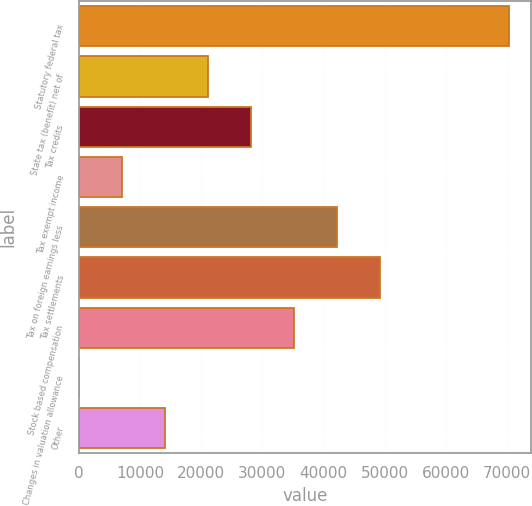Convert chart. <chart><loc_0><loc_0><loc_500><loc_500><bar_chart><fcel>Statutory federal tax<fcel>State tax (benefit) net of<fcel>Tax credits<fcel>Tax exempt income<fcel>Tax on foreign earnings less<fcel>Tax settlements<fcel>Stock based compensation<fcel>Changes in valuation allowance<fcel>Other<nl><fcel>70397<fcel>21126.1<fcel>28164.8<fcel>7048.7<fcel>42242.2<fcel>49280.9<fcel>35203.5<fcel>10<fcel>14087.4<nl></chart> 